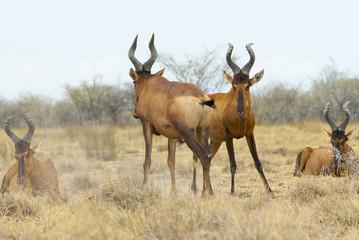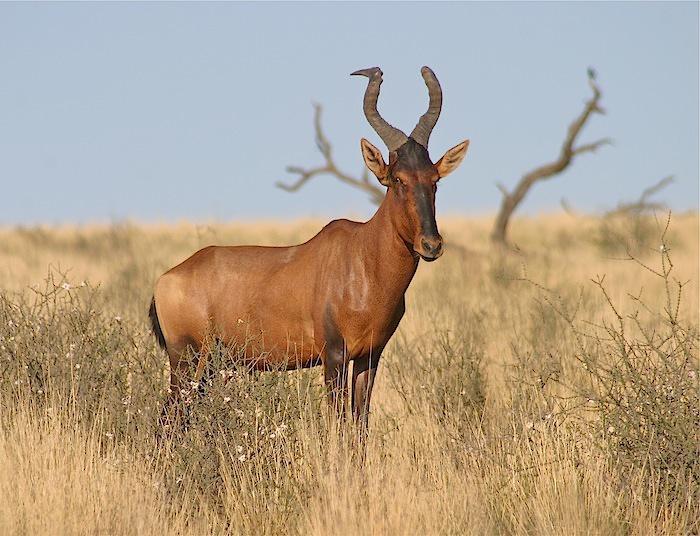The first image is the image on the left, the second image is the image on the right. For the images displayed, is the sentence "There are baby antelope in the image on the left." factually correct? Answer yes or no. No. The first image is the image on the left, the second image is the image on the right. Evaluate the accuracy of this statement regarding the images: "One of the images includes a single animal.". Is it true? Answer yes or no. Yes. 